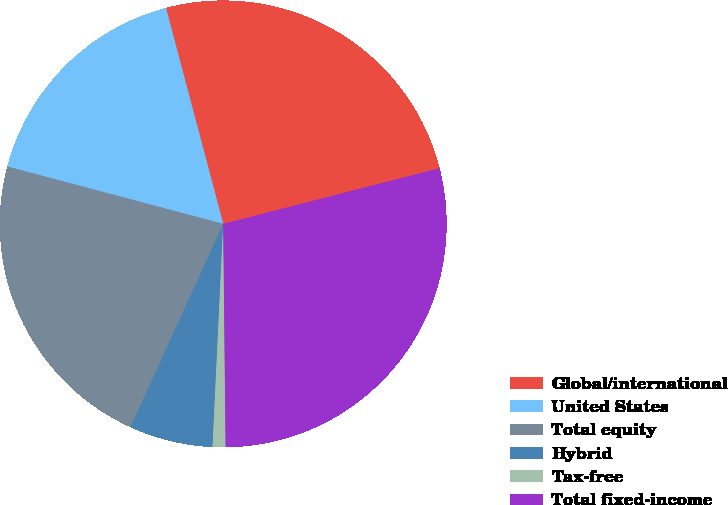<chart> <loc_0><loc_0><loc_500><loc_500><pie_chart><fcel>Global/international<fcel>United States<fcel>Total equity<fcel>Hybrid<fcel>Tax-free<fcel>Total fixed-income<nl><fcel>25.12%<fcel>16.74%<fcel>22.33%<fcel>6.05%<fcel>0.93%<fcel>28.84%<nl></chart> 